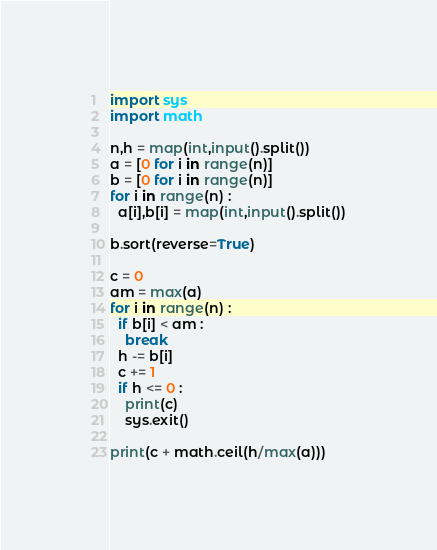<code> <loc_0><loc_0><loc_500><loc_500><_Python_>import sys
import math

n,h = map(int,input().split())
a = [0 for i in range(n)]
b = [0 for i in range(n)]
for i in range(n) :
  a[i],b[i] = map(int,input().split())
  
b.sort(reverse=True)

c = 0
am = max(a)
for i in range(n) :
  if b[i] < am :
    break
  h -= b[i]
  c += 1
  if h <= 0 :
    print(c)
    sys.exit()

print(c + math.ceil(h/max(a)))</code> 